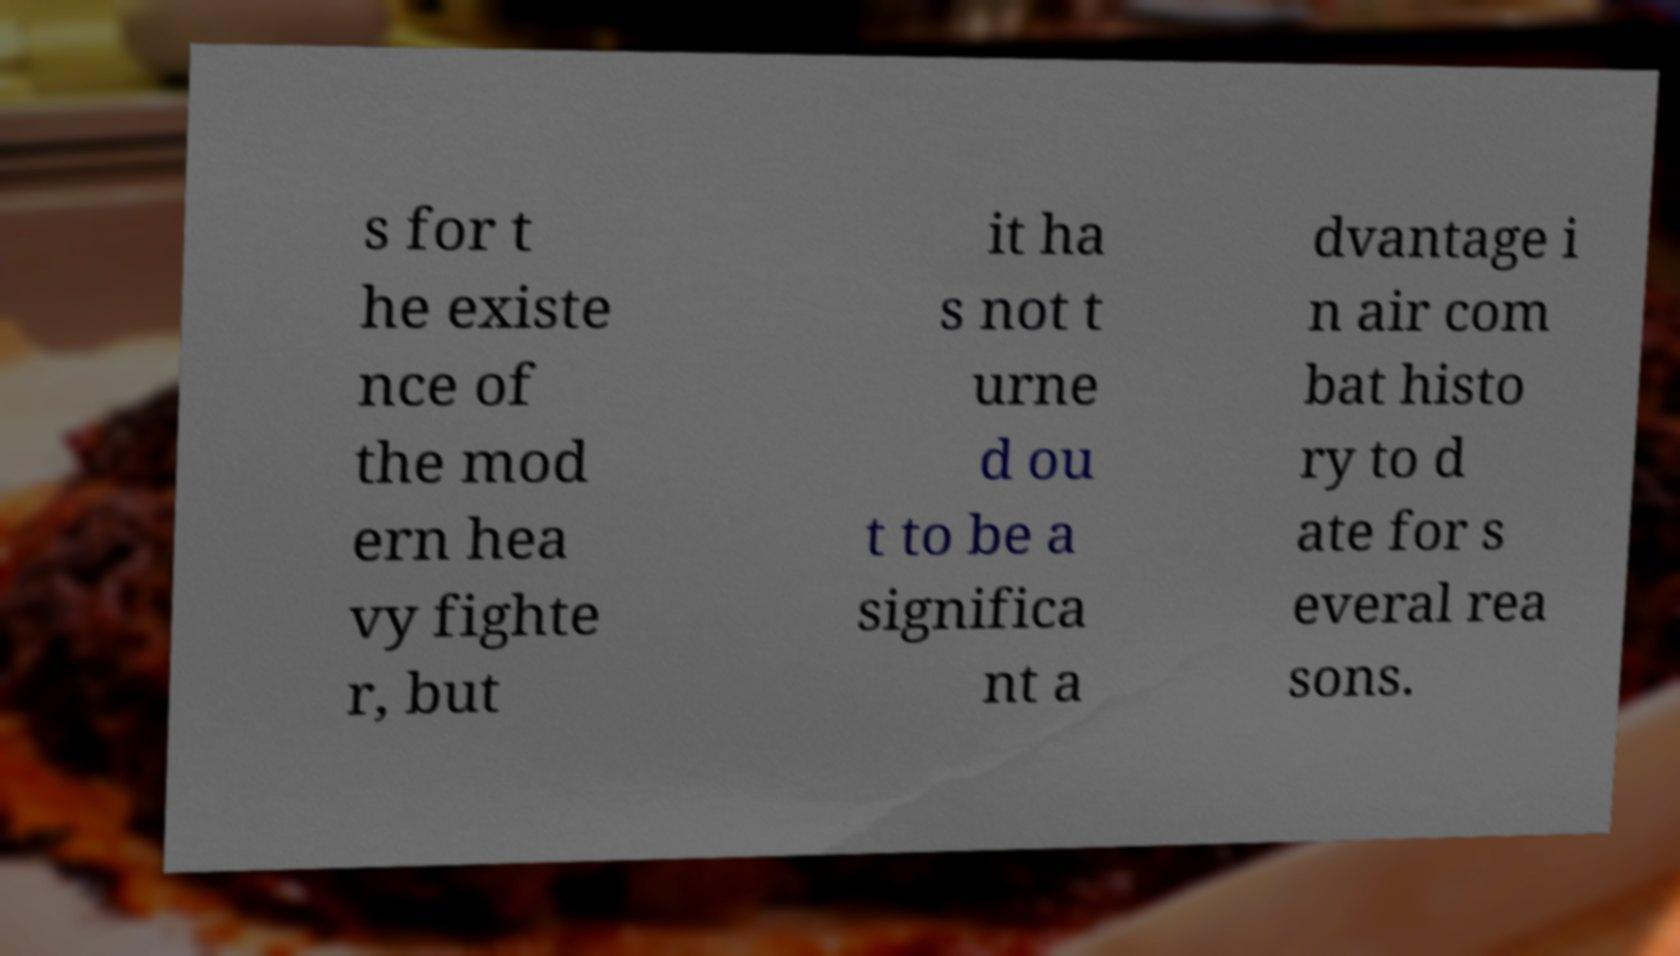I need the written content from this picture converted into text. Can you do that? s for t he existe nce of the mod ern hea vy fighte r, but it ha s not t urne d ou t to be a significa nt a dvantage i n air com bat histo ry to d ate for s everal rea sons. 